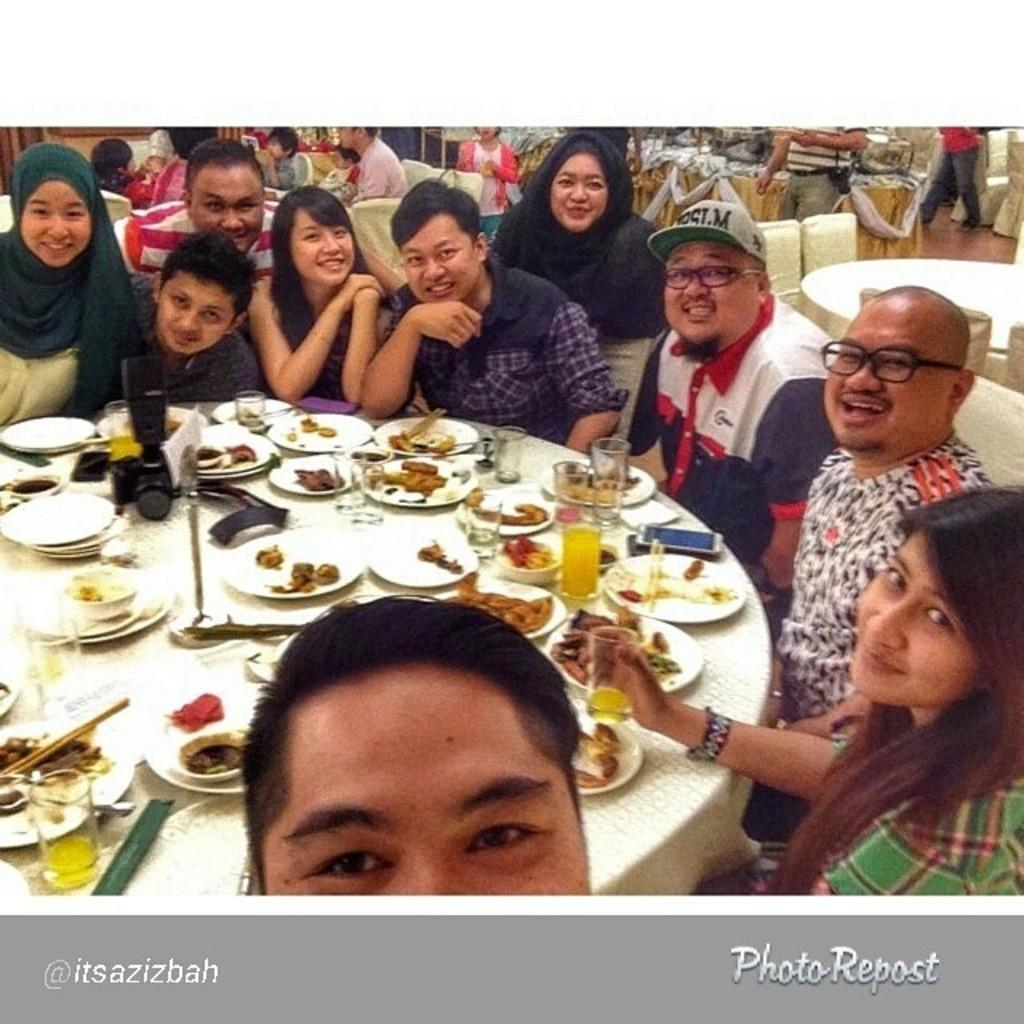What are the people in the image doing? The people in the image are sitting. What expression do the people have in the image? The people have smiles on their faces. What can be seen on the table in the image? There are plates with food and glasses on the table. What object related to photography is present on the table? There is a camera on the table. How many cows are visible in the image? There are no cows present in the image. What type of notebook is being used by the people in the image? There is no notebook present in the image. 